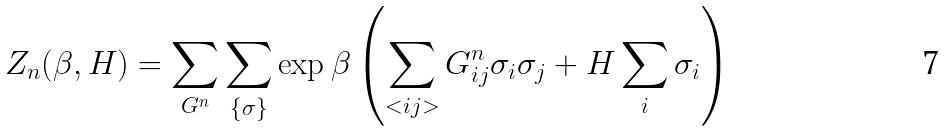Convert formula to latex. <formula><loc_0><loc_0><loc_500><loc_500>Z _ { n } ( \beta , H ) = \sum _ { G ^ { n } } \sum _ { \{ \sigma \} } \exp \beta \left ( \sum _ { < i j > } G _ { i j } ^ { n } \sigma _ { i } \sigma _ { j } + H \sum _ { i } \sigma _ { i } \right )</formula> 